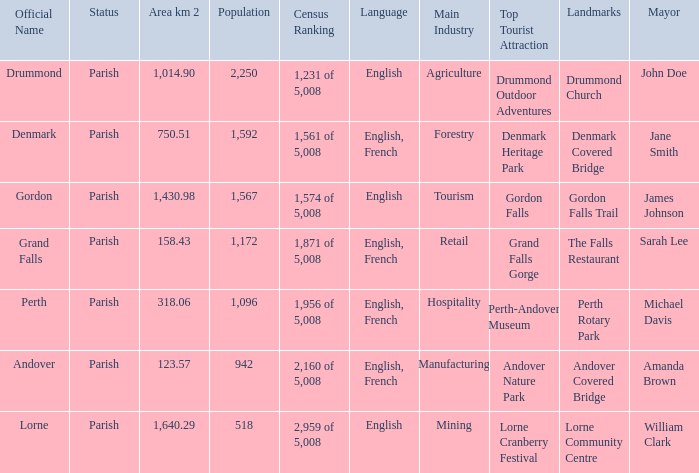Which parish has an area of 750.51? Denmark. 